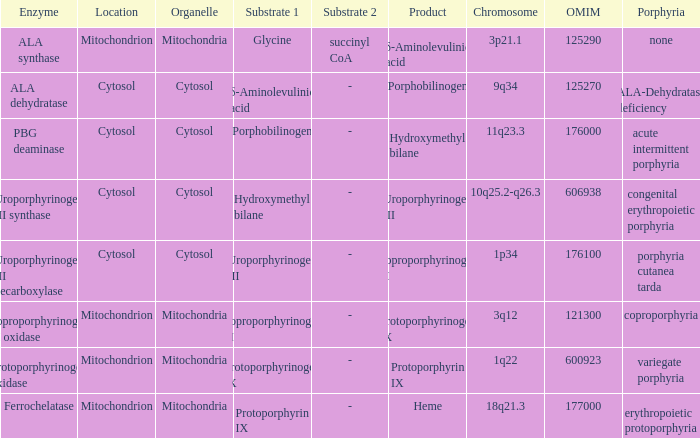What is protoporphyrin ix's substrate? Protoporphyrinogen IX. 